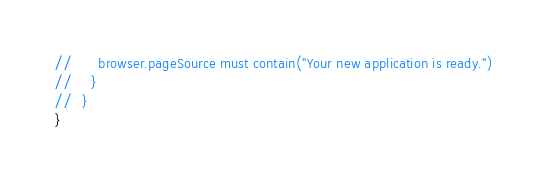<code> <loc_0><loc_0><loc_500><loc_500><_Scala_>//      browser.pageSource must contain("Your new application is ready.")
//    }
//  }
}
</code> 